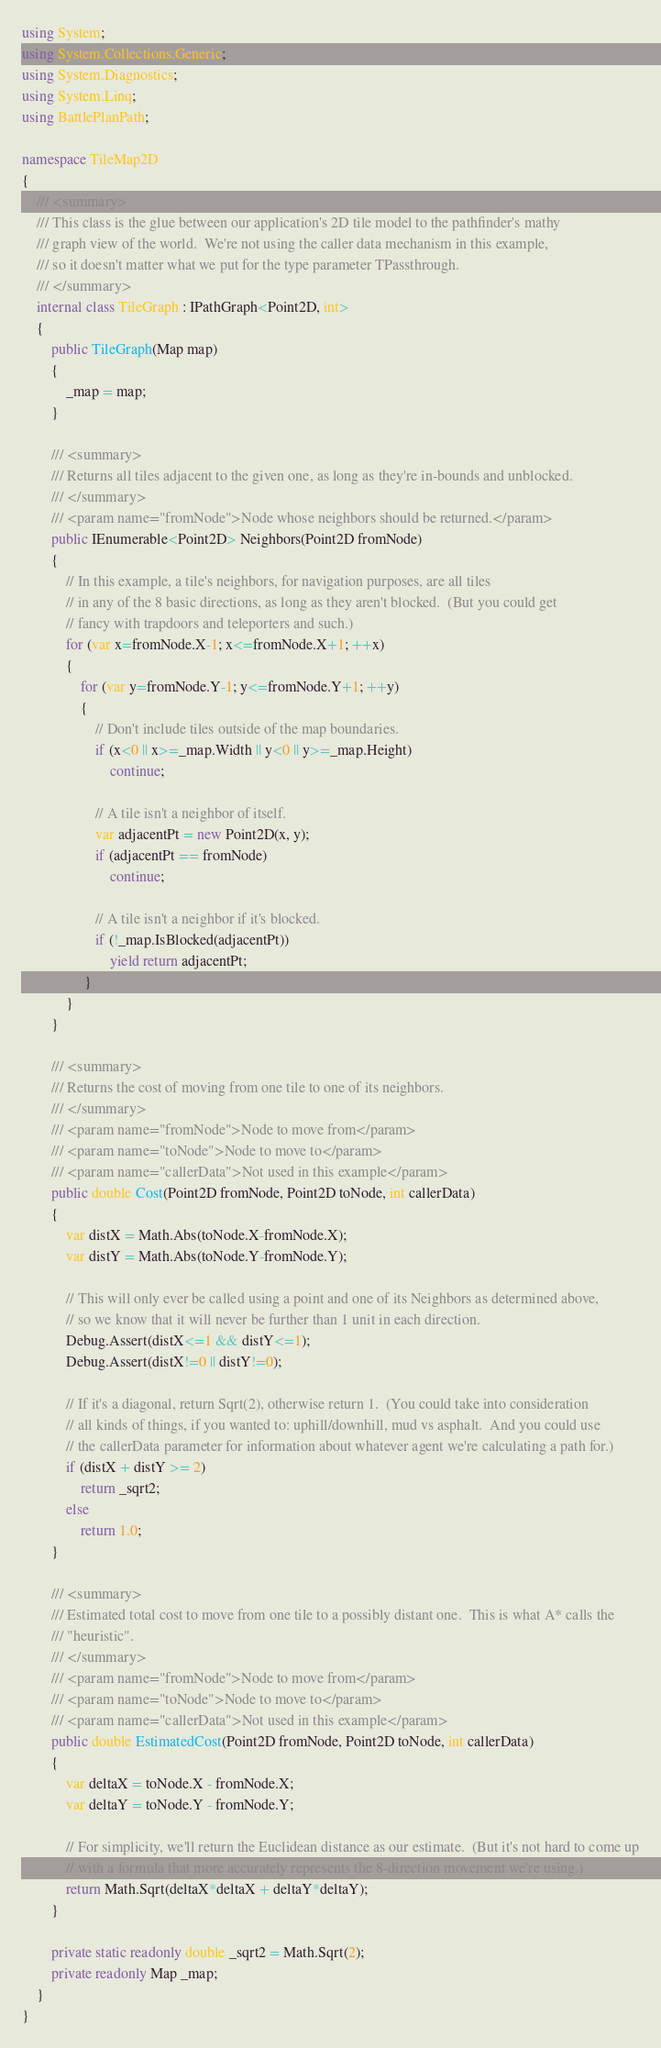<code> <loc_0><loc_0><loc_500><loc_500><_C#_>using System;
using System.Collections.Generic;
using System.Diagnostics;
using System.Linq;
using BattlePlanPath;

namespace TileMap2D
{
    /// <summary>
    /// This class is the glue between our application's 2D tile model to the pathfinder's mathy
    /// graph view of the world.  We're not using the caller data mechanism in this example,
    /// so it doesn't matter what we put for the type parameter TPassthrough.
    /// </summary>
    internal class TileGraph : IPathGraph<Point2D, int>
    {
        public TileGraph(Map map)
        {
            _map = map;
        }

        /// <summary>
        /// Returns all tiles adjacent to the given one, as long as they're in-bounds and unblocked.
        /// </summary>
        /// <param name="fromNode">Node whose neighbors should be returned.</param>
        public IEnumerable<Point2D> Neighbors(Point2D fromNode)
        {
            // In this example, a tile's neighbors, for navigation purposes, are all tiles
            // in any of the 8 basic directions, as long as they aren't blocked.  (But you could get
            // fancy with trapdoors and teleporters and such.)
            for (var x=fromNode.X-1; x<=fromNode.X+1; ++x)
            {
                for (var y=fromNode.Y-1; y<=fromNode.Y+1; ++y)
                {
                    // Don't include tiles outside of the map boundaries.
                    if (x<0 || x>=_map.Width || y<0 || y>=_map.Height)
                        continue;

                    // A tile isn't a neighbor of itself.
                    var adjacentPt = new Point2D(x, y);
                    if (adjacentPt == fromNode)
                        continue;

                    // A tile isn't a neighbor if it's blocked.
                    if (!_map.IsBlocked(adjacentPt))
                        yield return adjacentPt;
                 }
            }
        }

        /// <summary>
        /// Returns the cost of moving from one tile to one of its neighbors.
        /// </summary>
        /// <param name="fromNode">Node to move from</param>
        /// <param name="toNode">Node to move to</param>
        /// <param name="callerData">Not used in this example</param>
        public double Cost(Point2D fromNode, Point2D toNode, int callerData)
        {
            var distX = Math.Abs(toNode.X-fromNode.X);
            var distY = Math.Abs(toNode.Y-fromNode.Y);

            // This will only ever be called using a point and one of its Neighbors as determined above,
            // so we know that it will never be further than 1 unit in each direction.
            Debug.Assert(distX<=1 && distY<=1);
            Debug.Assert(distX!=0 || distY!=0);

            // If it's a diagonal, return Sqrt(2), otherwise return 1.  (You could take into consideration
            // all kinds of things, if you wanted to: uphill/downhill, mud vs asphalt.  And you could use
            // the callerData parameter for information about whatever agent we're calculating a path for.)
            if (distX + distY >= 2)
                return _sqrt2;
            else
                return 1.0;
        }

        /// <summary>
        /// Estimated total cost to move from one tile to a possibly distant one.  This is what A* calls the
        /// "heuristic".
        /// </summary>
        /// <param name="fromNode">Node to move from</param>
        /// <param name="toNode">Node to move to</param>
        /// <param name="callerData">Not used in this example</param>
        public double EstimatedCost(Point2D fromNode, Point2D toNode, int callerData)
        {
            var deltaX = toNode.X - fromNode.X;
            var deltaY = toNode.Y - fromNode.Y;

            // For simplicity, we'll return the Euclidean distance as our estimate.  (But it's not hard to come up
            // with a formula that more accurately represents the 8-direction movement we're using.)
            return Math.Sqrt(deltaX*deltaX + deltaY*deltaY);
        }

        private static readonly double _sqrt2 = Math.Sqrt(2);
        private readonly Map _map;
    }
}</code> 